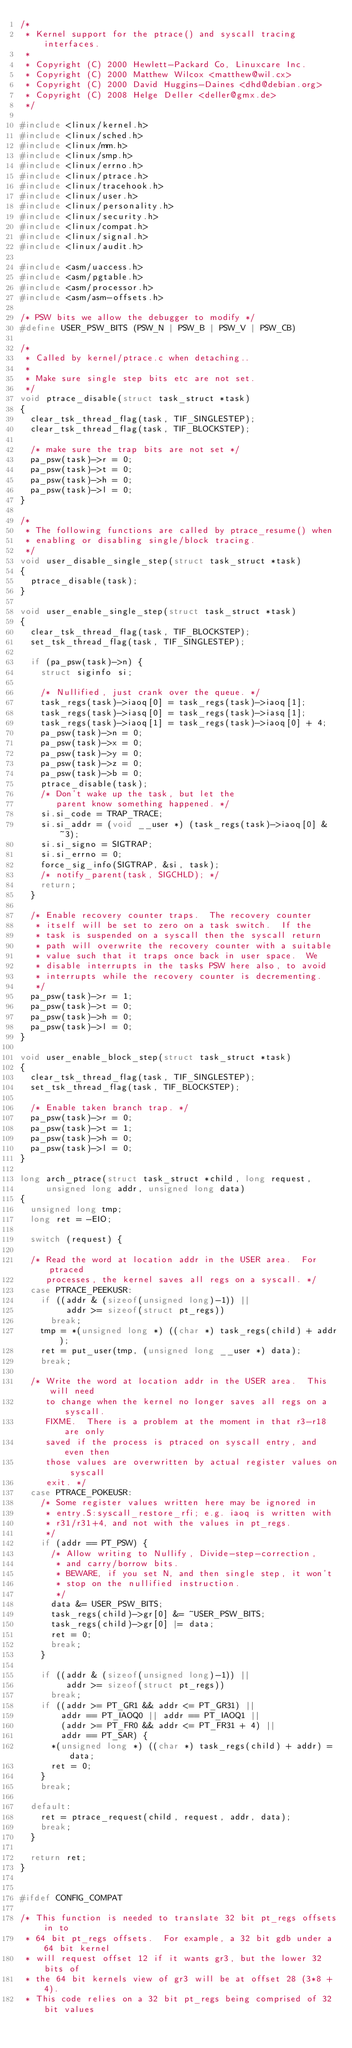<code> <loc_0><loc_0><loc_500><loc_500><_C_>/*
 * Kernel support for the ptrace() and syscall tracing interfaces.
 *
 * Copyright (C) 2000 Hewlett-Packard Co, Linuxcare Inc.
 * Copyright (C) 2000 Matthew Wilcox <matthew@wil.cx>
 * Copyright (C) 2000 David Huggins-Daines <dhd@debian.org>
 * Copyright (C) 2008 Helge Deller <deller@gmx.de>
 */

#include <linux/kernel.h>
#include <linux/sched.h>
#include <linux/mm.h>
#include <linux/smp.h>
#include <linux/errno.h>
#include <linux/ptrace.h>
#include <linux/tracehook.h>
#include <linux/user.h>
#include <linux/personality.h>
#include <linux/security.h>
#include <linux/compat.h>
#include <linux/signal.h>
#include <linux/audit.h>

#include <asm/uaccess.h>
#include <asm/pgtable.h>
#include <asm/processor.h>
#include <asm/asm-offsets.h>

/* PSW bits we allow the debugger to modify */
#define USER_PSW_BITS	(PSW_N | PSW_B | PSW_V | PSW_CB)

/*
 * Called by kernel/ptrace.c when detaching..
 *
 * Make sure single step bits etc are not set.
 */
void ptrace_disable(struct task_struct *task)
{
	clear_tsk_thread_flag(task, TIF_SINGLESTEP);
	clear_tsk_thread_flag(task, TIF_BLOCKSTEP);

	/* make sure the trap bits are not set */
	pa_psw(task)->r = 0;
	pa_psw(task)->t = 0;
	pa_psw(task)->h = 0;
	pa_psw(task)->l = 0;
}

/*
 * The following functions are called by ptrace_resume() when
 * enabling or disabling single/block tracing.
 */
void user_disable_single_step(struct task_struct *task)
{
	ptrace_disable(task);
}

void user_enable_single_step(struct task_struct *task)
{
	clear_tsk_thread_flag(task, TIF_BLOCKSTEP);
	set_tsk_thread_flag(task, TIF_SINGLESTEP);

	if (pa_psw(task)->n) {
		struct siginfo si;

		/* Nullified, just crank over the queue. */
		task_regs(task)->iaoq[0] = task_regs(task)->iaoq[1];
		task_regs(task)->iasq[0] = task_regs(task)->iasq[1];
		task_regs(task)->iaoq[1] = task_regs(task)->iaoq[0] + 4;
		pa_psw(task)->n = 0;
		pa_psw(task)->x = 0;
		pa_psw(task)->y = 0;
		pa_psw(task)->z = 0;
		pa_psw(task)->b = 0;
		ptrace_disable(task);
		/* Don't wake up the task, but let the
		   parent know something happened. */
		si.si_code = TRAP_TRACE;
		si.si_addr = (void __user *) (task_regs(task)->iaoq[0] & ~3);
		si.si_signo = SIGTRAP;
		si.si_errno = 0;
		force_sig_info(SIGTRAP, &si, task);
		/* notify_parent(task, SIGCHLD); */
		return;
	}

	/* Enable recovery counter traps.  The recovery counter
	 * itself will be set to zero on a task switch.  If the
	 * task is suspended on a syscall then the syscall return
	 * path will overwrite the recovery counter with a suitable
	 * value such that it traps once back in user space.  We
	 * disable interrupts in the tasks PSW here also, to avoid
	 * interrupts while the recovery counter is decrementing.
	 */
	pa_psw(task)->r = 1;
	pa_psw(task)->t = 0;
	pa_psw(task)->h = 0;
	pa_psw(task)->l = 0;
}

void user_enable_block_step(struct task_struct *task)
{
	clear_tsk_thread_flag(task, TIF_SINGLESTEP);
	set_tsk_thread_flag(task, TIF_BLOCKSTEP);

	/* Enable taken branch trap. */
	pa_psw(task)->r = 0;
	pa_psw(task)->t = 1;
	pa_psw(task)->h = 0;
	pa_psw(task)->l = 0;
}

long arch_ptrace(struct task_struct *child, long request,
		 unsigned long addr, unsigned long data)
{
	unsigned long tmp;
	long ret = -EIO;

	switch (request) {

	/* Read the word at location addr in the USER area.  For ptraced
	   processes, the kernel saves all regs on a syscall. */
	case PTRACE_PEEKUSR:
		if ((addr & (sizeof(unsigned long)-1)) ||
		     addr >= sizeof(struct pt_regs))
			break;
		tmp = *(unsigned long *) ((char *) task_regs(child) + addr);
		ret = put_user(tmp, (unsigned long __user *) data);
		break;

	/* Write the word at location addr in the USER area.  This will need
	   to change when the kernel no longer saves all regs on a syscall.
	   FIXME.  There is a problem at the moment in that r3-r18 are only
	   saved if the process is ptraced on syscall entry, and even then
	   those values are overwritten by actual register values on syscall
	   exit. */
	case PTRACE_POKEUSR:
		/* Some register values written here may be ignored in
		 * entry.S:syscall_restore_rfi; e.g. iaoq is written with
		 * r31/r31+4, and not with the values in pt_regs.
		 */
		if (addr == PT_PSW) {
			/* Allow writing to Nullify, Divide-step-correction,
			 * and carry/borrow bits.
			 * BEWARE, if you set N, and then single step, it won't
			 * stop on the nullified instruction.
			 */
			data &= USER_PSW_BITS;
			task_regs(child)->gr[0] &= ~USER_PSW_BITS;
			task_regs(child)->gr[0] |= data;
			ret = 0;
			break;
		}

		if ((addr & (sizeof(unsigned long)-1)) ||
		     addr >= sizeof(struct pt_regs))
			break;
		if ((addr >= PT_GR1 && addr <= PT_GR31) ||
				addr == PT_IAOQ0 || addr == PT_IAOQ1 ||
				(addr >= PT_FR0 && addr <= PT_FR31 + 4) ||
				addr == PT_SAR) {
			*(unsigned long *) ((char *) task_regs(child) + addr) = data;
			ret = 0;
		}
		break;

	default:
		ret = ptrace_request(child, request, addr, data);
		break;
	}

	return ret;
}


#ifdef CONFIG_COMPAT

/* This function is needed to translate 32 bit pt_regs offsets in to
 * 64 bit pt_regs offsets.  For example, a 32 bit gdb under a 64 bit kernel
 * will request offset 12 if it wants gr3, but the lower 32 bits of
 * the 64 bit kernels view of gr3 will be at offset 28 (3*8 + 4).
 * This code relies on a 32 bit pt_regs being comprised of 32 bit values</code> 